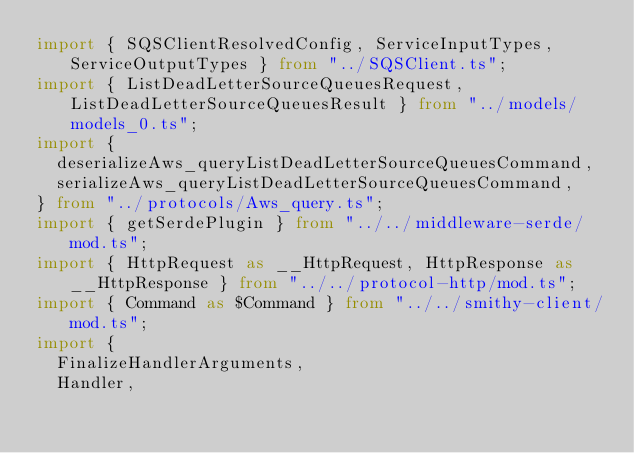<code> <loc_0><loc_0><loc_500><loc_500><_TypeScript_>import { SQSClientResolvedConfig, ServiceInputTypes, ServiceOutputTypes } from "../SQSClient.ts";
import { ListDeadLetterSourceQueuesRequest, ListDeadLetterSourceQueuesResult } from "../models/models_0.ts";
import {
  deserializeAws_queryListDeadLetterSourceQueuesCommand,
  serializeAws_queryListDeadLetterSourceQueuesCommand,
} from "../protocols/Aws_query.ts";
import { getSerdePlugin } from "../../middleware-serde/mod.ts";
import { HttpRequest as __HttpRequest, HttpResponse as __HttpResponse } from "../../protocol-http/mod.ts";
import { Command as $Command } from "../../smithy-client/mod.ts";
import {
  FinalizeHandlerArguments,
  Handler,</code> 